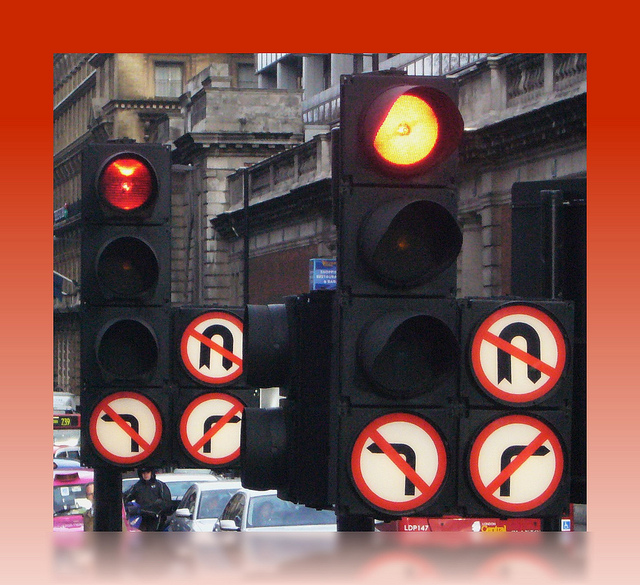Identify the text contained in this image. LOP147 